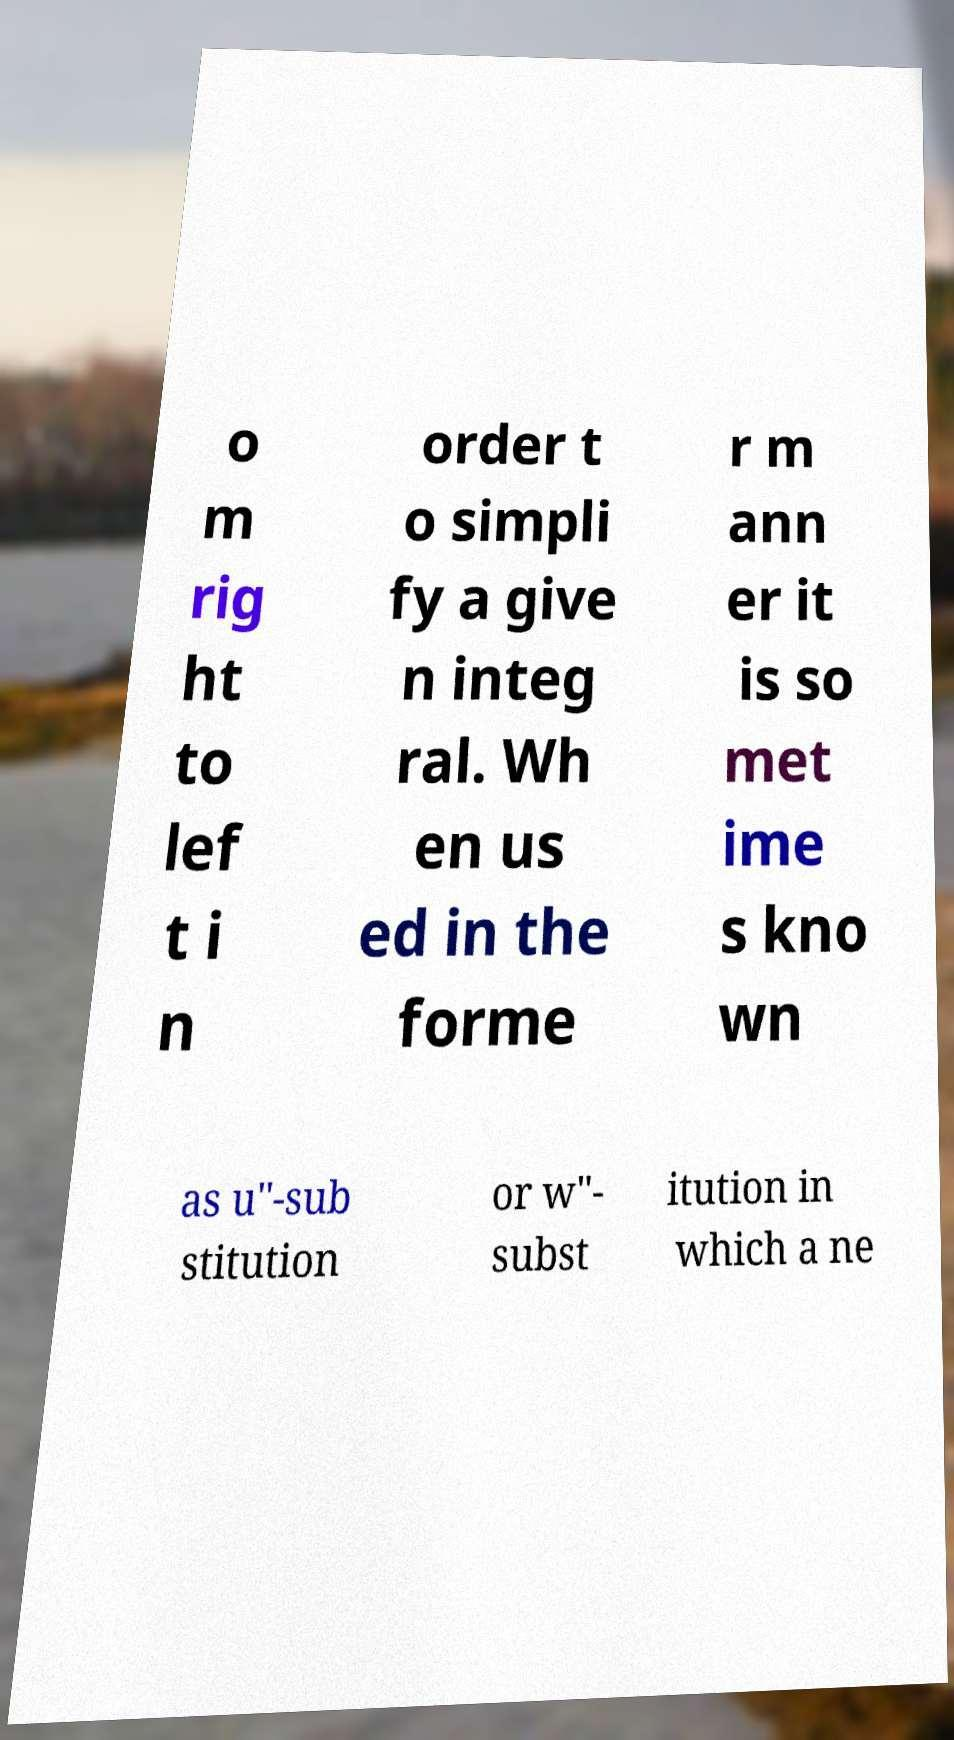For documentation purposes, I need the text within this image transcribed. Could you provide that? o m rig ht to lef t i n order t o simpli fy a give n integ ral. Wh en us ed in the forme r m ann er it is so met ime s kno wn as u"-sub stitution or w"- subst itution in which a ne 